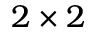Convert formula to latex. <formula><loc_0><loc_0><loc_500><loc_500>2 \times 2</formula> 